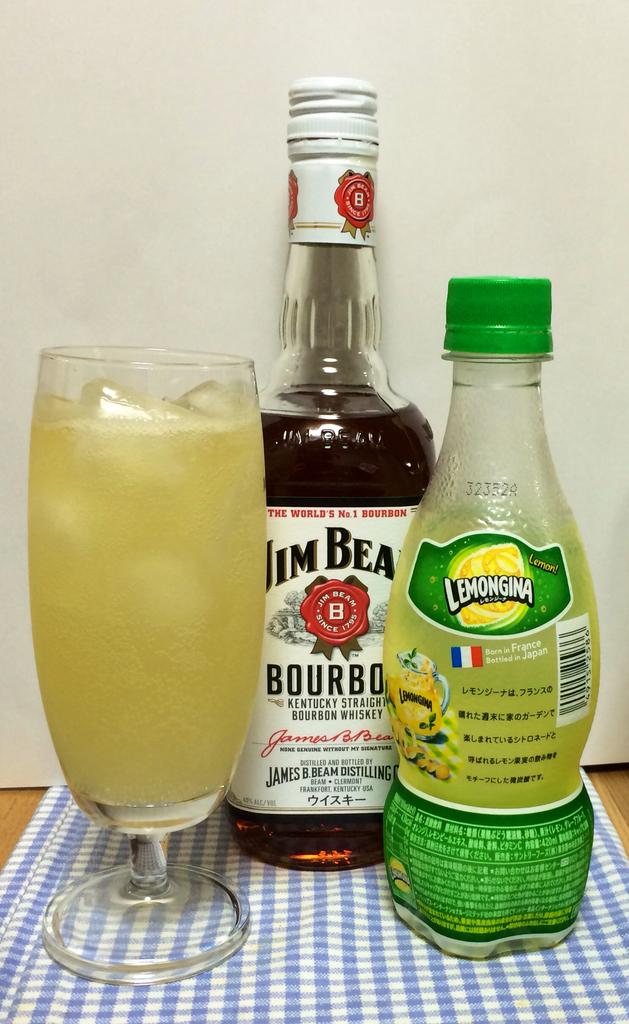What type of drinks are these?
Provide a short and direct response. Lemeongina. Where is the bourbon from?
Your response must be concise. Kentucky. 